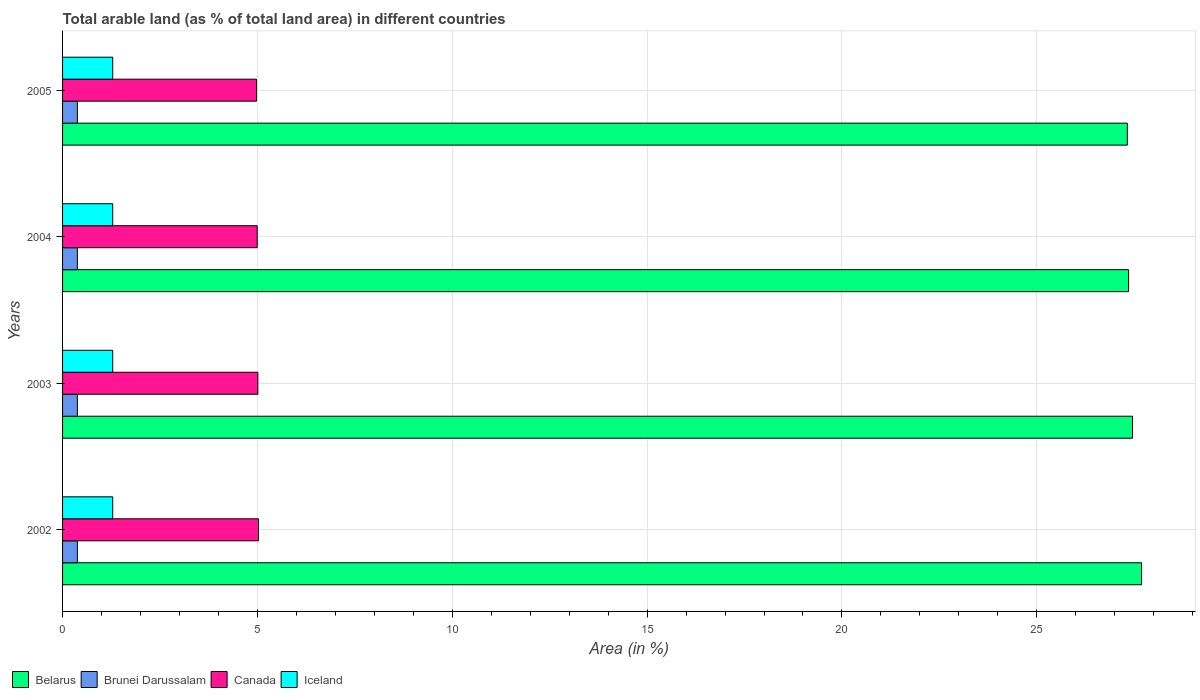Are the number of bars per tick equal to the number of legend labels?
Your answer should be compact. Yes. What is the percentage of arable land in Belarus in 2003?
Provide a short and direct response. 27.46. Across all years, what is the maximum percentage of arable land in Iceland?
Give a very brief answer. 1.29. Across all years, what is the minimum percentage of arable land in Belarus?
Give a very brief answer. 27.32. In which year was the percentage of arable land in Belarus minimum?
Keep it short and to the point. 2005. What is the total percentage of arable land in Brunei Darussalam in the graph?
Keep it short and to the point. 1.52. What is the difference between the percentage of arable land in Iceland in 2004 and the percentage of arable land in Brunei Darussalam in 2002?
Give a very brief answer. 0.91. What is the average percentage of arable land in Belarus per year?
Your response must be concise. 27.46. In the year 2005, what is the difference between the percentage of arable land in Brunei Darussalam and percentage of arable land in Canada?
Provide a succinct answer. -4.6. What is the ratio of the percentage of arable land in Canada in 2002 to that in 2003?
Keep it short and to the point. 1. What is the difference between the highest and the second highest percentage of arable land in Canada?
Your answer should be compact. 0.02. What is the difference between the highest and the lowest percentage of arable land in Belarus?
Make the answer very short. 0.36. In how many years, is the percentage of arable land in Canada greater than the average percentage of arable land in Canada taken over all years?
Provide a short and direct response. 2. Is the sum of the percentage of arable land in Belarus in 2003 and 2005 greater than the maximum percentage of arable land in Brunei Darussalam across all years?
Provide a succinct answer. Yes. Is it the case that in every year, the sum of the percentage of arable land in Iceland and percentage of arable land in Belarus is greater than the sum of percentage of arable land in Canada and percentage of arable land in Brunei Darussalam?
Offer a terse response. Yes. What does the 3rd bar from the top in 2005 represents?
Give a very brief answer. Brunei Darussalam. What does the 2nd bar from the bottom in 2005 represents?
Offer a very short reply. Brunei Darussalam. How many bars are there?
Offer a terse response. 16. Are all the bars in the graph horizontal?
Your answer should be compact. Yes. What is the difference between two consecutive major ticks on the X-axis?
Offer a terse response. 5. Where does the legend appear in the graph?
Your response must be concise. Bottom left. How many legend labels are there?
Make the answer very short. 4. How are the legend labels stacked?
Offer a very short reply. Horizontal. What is the title of the graph?
Provide a succinct answer. Total arable land (as % of total land area) in different countries. Does "Botswana" appear as one of the legend labels in the graph?
Ensure brevity in your answer.  No. What is the label or title of the X-axis?
Provide a short and direct response. Area (in %). What is the label or title of the Y-axis?
Give a very brief answer. Years. What is the Area (in %) of Belarus in 2002?
Provide a succinct answer. 27.69. What is the Area (in %) of Brunei Darussalam in 2002?
Provide a succinct answer. 0.38. What is the Area (in %) of Canada in 2002?
Offer a very short reply. 5.03. What is the Area (in %) of Iceland in 2002?
Give a very brief answer. 1.29. What is the Area (in %) in Belarus in 2003?
Provide a short and direct response. 27.46. What is the Area (in %) in Brunei Darussalam in 2003?
Provide a short and direct response. 0.38. What is the Area (in %) of Canada in 2003?
Keep it short and to the point. 5.01. What is the Area (in %) in Iceland in 2003?
Provide a short and direct response. 1.29. What is the Area (in %) of Belarus in 2004?
Ensure brevity in your answer.  27.36. What is the Area (in %) in Brunei Darussalam in 2004?
Offer a terse response. 0.38. What is the Area (in %) in Canada in 2004?
Give a very brief answer. 4.99. What is the Area (in %) of Iceland in 2004?
Give a very brief answer. 1.29. What is the Area (in %) of Belarus in 2005?
Provide a short and direct response. 27.32. What is the Area (in %) in Brunei Darussalam in 2005?
Provide a short and direct response. 0.38. What is the Area (in %) of Canada in 2005?
Your answer should be very brief. 4.98. What is the Area (in %) of Iceland in 2005?
Your answer should be compact. 1.29. Across all years, what is the maximum Area (in %) of Belarus?
Your response must be concise. 27.69. Across all years, what is the maximum Area (in %) of Brunei Darussalam?
Give a very brief answer. 0.38. Across all years, what is the maximum Area (in %) in Canada?
Ensure brevity in your answer.  5.03. Across all years, what is the maximum Area (in %) in Iceland?
Offer a terse response. 1.29. Across all years, what is the minimum Area (in %) of Belarus?
Your answer should be very brief. 27.32. Across all years, what is the minimum Area (in %) of Brunei Darussalam?
Give a very brief answer. 0.38. Across all years, what is the minimum Area (in %) of Canada?
Make the answer very short. 4.98. Across all years, what is the minimum Area (in %) of Iceland?
Your answer should be very brief. 1.29. What is the total Area (in %) in Belarus in the graph?
Offer a terse response. 109.82. What is the total Area (in %) of Brunei Darussalam in the graph?
Keep it short and to the point. 1.52. What is the total Area (in %) in Canada in the graph?
Give a very brief answer. 20.01. What is the total Area (in %) in Iceland in the graph?
Offer a very short reply. 5.15. What is the difference between the Area (in %) of Belarus in 2002 and that in 2003?
Ensure brevity in your answer.  0.23. What is the difference between the Area (in %) in Brunei Darussalam in 2002 and that in 2003?
Your answer should be compact. 0. What is the difference between the Area (in %) of Canada in 2002 and that in 2003?
Make the answer very short. 0.02. What is the difference between the Area (in %) of Belarus in 2002 and that in 2004?
Keep it short and to the point. 0.33. What is the difference between the Area (in %) of Brunei Darussalam in 2002 and that in 2004?
Provide a succinct answer. 0. What is the difference between the Area (in %) of Canada in 2002 and that in 2004?
Offer a very short reply. 0.03. What is the difference between the Area (in %) in Iceland in 2002 and that in 2004?
Offer a very short reply. 0. What is the difference between the Area (in %) of Belarus in 2002 and that in 2005?
Your response must be concise. 0.36. What is the difference between the Area (in %) of Canada in 2002 and that in 2005?
Your response must be concise. 0.05. What is the difference between the Area (in %) of Iceland in 2002 and that in 2005?
Provide a short and direct response. 0. What is the difference between the Area (in %) of Belarus in 2003 and that in 2004?
Your response must be concise. 0.1. What is the difference between the Area (in %) of Canada in 2003 and that in 2004?
Offer a very short reply. 0.02. What is the difference between the Area (in %) in Belarus in 2003 and that in 2005?
Make the answer very short. 0.13. What is the difference between the Area (in %) in Brunei Darussalam in 2003 and that in 2005?
Ensure brevity in your answer.  0. What is the difference between the Area (in %) in Canada in 2003 and that in 2005?
Offer a terse response. 0.03. What is the difference between the Area (in %) in Iceland in 2003 and that in 2005?
Give a very brief answer. 0. What is the difference between the Area (in %) in Belarus in 2004 and that in 2005?
Keep it short and to the point. 0.03. What is the difference between the Area (in %) in Brunei Darussalam in 2004 and that in 2005?
Keep it short and to the point. 0. What is the difference between the Area (in %) in Canada in 2004 and that in 2005?
Provide a succinct answer. 0.02. What is the difference between the Area (in %) in Belarus in 2002 and the Area (in %) in Brunei Darussalam in 2003?
Give a very brief answer. 27.31. What is the difference between the Area (in %) of Belarus in 2002 and the Area (in %) of Canada in 2003?
Your answer should be very brief. 22.68. What is the difference between the Area (in %) of Belarus in 2002 and the Area (in %) of Iceland in 2003?
Offer a terse response. 26.4. What is the difference between the Area (in %) in Brunei Darussalam in 2002 and the Area (in %) in Canada in 2003?
Offer a very short reply. -4.63. What is the difference between the Area (in %) in Brunei Darussalam in 2002 and the Area (in %) in Iceland in 2003?
Offer a terse response. -0.91. What is the difference between the Area (in %) of Canada in 2002 and the Area (in %) of Iceland in 2003?
Make the answer very short. 3.74. What is the difference between the Area (in %) of Belarus in 2002 and the Area (in %) of Brunei Darussalam in 2004?
Offer a terse response. 27.31. What is the difference between the Area (in %) in Belarus in 2002 and the Area (in %) in Canada in 2004?
Offer a terse response. 22.69. What is the difference between the Area (in %) of Belarus in 2002 and the Area (in %) of Iceland in 2004?
Your response must be concise. 26.4. What is the difference between the Area (in %) in Brunei Darussalam in 2002 and the Area (in %) in Canada in 2004?
Make the answer very short. -4.62. What is the difference between the Area (in %) in Brunei Darussalam in 2002 and the Area (in %) in Iceland in 2004?
Make the answer very short. -0.91. What is the difference between the Area (in %) of Canada in 2002 and the Area (in %) of Iceland in 2004?
Offer a very short reply. 3.74. What is the difference between the Area (in %) in Belarus in 2002 and the Area (in %) in Brunei Darussalam in 2005?
Your answer should be very brief. 27.31. What is the difference between the Area (in %) of Belarus in 2002 and the Area (in %) of Canada in 2005?
Provide a short and direct response. 22.71. What is the difference between the Area (in %) in Belarus in 2002 and the Area (in %) in Iceland in 2005?
Make the answer very short. 26.4. What is the difference between the Area (in %) in Brunei Darussalam in 2002 and the Area (in %) in Canada in 2005?
Give a very brief answer. -4.6. What is the difference between the Area (in %) in Brunei Darussalam in 2002 and the Area (in %) in Iceland in 2005?
Give a very brief answer. -0.91. What is the difference between the Area (in %) of Canada in 2002 and the Area (in %) of Iceland in 2005?
Your response must be concise. 3.74. What is the difference between the Area (in %) in Belarus in 2003 and the Area (in %) in Brunei Darussalam in 2004?
Your answer should be very brief. 27.08. What is the difference between the Area (in %) in Belarus in 2003 and the Area (in %) in Canada in 2004?
Your answer should be very brief. 22.46. What is the difference between the Area (in %) of Belarus in 2003 and the Area (in %) of Iceland in 2004?
Make the answer very short. 26.17. What is the difference between the Area (in %) in Brunei Darussalam in 2003 and the Area (in %) in Canada in 2004?
Your answer should be very brief. -4.62. What is the difference between the Area (in %) of Brunei Darussalam in 2003 and the Area (in %) of Iceland in 2004?
Offer a terse response. -0.91. What is the difference between the Area (in %) in Canada in 2003 and the Area (in %) in Iceland in 2004?
Provide a short and direct response. 3.72. What is the difference between the Area (in %) of Belarus in 2003 and the Area (in %) of Brunei Darussalam in 2005?
Provide a short and direct response. 27.08. What is the difference between the Area (in %) in Belarus in 2003 and the Area (in %) in Canada in 2005?
Your answer should be very brief. 22.48. What is the difference between the Area (in %) in Belarus in 2003 and the Area (in %) in Iceland in 2005?
Make the answer very short. 26.17. What is the difference between the Area (in %) of Brunei Darussalam in 2003 and the Area (in %) of Canada in 2005?
Keep it short and to the point. -4.6. What is the difference between the Area (in %) in Brunei Darussalam in 2003 and the Area (in %) in Iceland in 2005?
Keep it short and to the point. -0.91. What is the difference between the Area (in %) of Canada in 2003 and the Area (in %) of Iceland in 2005?
Offer a very short reply. 3.72. What is the difference between the Area (in %) in Belarus in 2004 and the Area (in %) in Brunei Darussalam in 2005?
Your answer should be compact. 26.98. What is the difference between the Area (in %) in Belarus in 2004 and the Area (in %) in Canada in 2005?
Your answer should be compact. 22.38. What is the difference between the Area (in %) in Belarus in 2004 and the Area (in %) in Iceland in 2005?
Ensure brevity in your answer.  26.07. What is the difference between the Area (in %) in Brunei Darussalam in 2004 and the Area (in %) in Canada in 2005?
Your response must be concise. -4.6. What is the difference between the Area (in %) of Brunei Darussalam in 2004 and the Area (in %) of Iceland in 2005?
Make the answer very short. -0.91. What is the difference between the Area (in %) in Canada in 2004 and the Area (in %) in Iceland in 2005?
Give a very brief answer. 3.71. What is the average Area (in %) in Belarus per year?
Ensure brevity in your answer.  27.46. What is the average Area (in %) of Brunei Darussalam per year?
Offer a terse response. 0.38. What is the average Area (in %) in Canada per year?
Your response must be concise. 5. What is the average Area (in %) in Iceland per year?
Keep it short and to the point. 1.29. In the year 2002, what is the difference between the Area (in %) of Belarus and Area (in %) of Brunei Darussalam?
Make the answer very short. 27.31. In the year 2002, what is the difference between the Area (in %) of Belarus and Area (in %) of Canada?
Offer a very short reply. 22.66. In the year 2002, what is the difference between the Area (in %) in Belarus and Area (in %) in Iceland?
Your answer should be very brief. 26.4. In the year 2002, what is the difference between the Area (in %) of Brunei Darussalam and Area (in %) of Canada?
Offer a very short reply. -4.65. In the year 2002, what is the difference between the Area (in %) in Brunei Darussalam and Area (in %) in Iceland?
Give a very brief answer. -0.91. In the year 2002, what is the difference between the Area (in %) of Canada and Area (in %) of Iceland?
Offer a terse response. 3.74. In the year 2003, what is the difference between the Area (in %) in Belarus and Area (in %) in Brunei Darussalam?
Give a very brief answer. 27.08. In the year 2003, what is the difference between the Area (in %) in Belarus and Area (in %) in Canada?
Provide a succinct answer. 22.44. In the year 2003, what is the difference between the Area (in %) in Belarus and Area (in %) in Iceland?
Ensure brevity in your answer.  26.17. In the year 2003, what is the difference between the Area (in %) in Brunei Darussalam and Area (in %) in Canada?
Make the answer very short. -4.63. In the year 2003, what is the difference between the Area (in %) in Brunei Darussalam and Area (in %) in Iceland?
Make the answer very short. -0.91. In the year 2003, what is the difference between the Area (in %) of Canada and Area (in %) of Iceland?
Offer a terse response. 3.72. In the year 2004, what is the difference between the Area (in %) in Belarus and Area (in %) in Brunei Darussalam?
Your response must be concise. 26.98. In the year 2004, what is the difference between the Area (in %) in Belarus and Area (in %) in Canada?
Your answer should be very brief. 22.36. In the year 2004, what is the difference between the Area (in %) of Belarus and Area (in %) of Iceland?
Your answer should be compact. 26.07. In the year 2004, what is the difference between the Area (in %) of Brunei Darussalam and Area (in %) of Canada?
Offer a terse response. -4.62. In the year 2004, what is the difference between the Area (in %) in Brunei Darussalam and Area (in %) in Iceland?
Keep it short and to the point. -0.91. In the year 2004, what is the difference between the Area (in %) in Canada and Area (in %) in Iceland?
Provide a short and direct response. 3.71. In the year 2005, what is the difference between the Area (in %) of Belarus and Area (in %) of Brunei Darussalam?
Give a very brief answer. 26.94. In the year 2005, what is the difference between the Area (in %) in Belarus and Area (in %) in Canada?
Your answer should be very brief. 22.35. In the year 2005, what is the difference between the Area (in %) in Belarus and Area (in %) in Iceland?
Ensure brevity in your answer.  26.04. In the year 2005, what is the difference between the Area (in %) in Brunei Darussalam and Area (in %) in Canada?
Your response must be concise. -4.6. In the year 2005, what is the difference between the Area (in %) in Brunei Darussalam and Area (in %) in Iceland?
Provide a short and direct response. -0.91. In the year 2005, what is the difference between the Area (in %) of Canada and Area (in %) of Iceland?
Provide a succinct answer. 3.69. What is the ratio of the Area (in %) of Belarus in 2002 to that in 2003?
Provide a succinct answer. 1.01. What is the ratio of the Area (in %) of Brunei Darussalam in 2002 to that in 2003?
Offer a very short reply. 1. What is the ratio of the Area (in %) in Belarus in 2002 to that in 2004?
Make the answer very short. 1.01. What is the ratio of the Area (in %) in Brunei Darussalam in 2002 to that in 2004?
Provide a succinct answer. 1. What is the ratio of the Area (in %) in Canada in 2002 to that in 2004?
Make the answer very short. 1.01. What is the ratio of the Area (in %) in Iceland in 2002 to that in 2004?
Your answer should be compact. 1. What is the ratio of the Area (in %) of Belarus in 2002 to that in 2005?
Ensure brevity in your answer.  1.01. What is the ratio of the Area (in %) of Canada in 2002 to that in 2005?
Ensure brevity in your answer.  1.01. What is the ratio of the Area (in %) in Iceland in 2002 to that in 2005?
Give a very brief answer. 1. What is the ratio of the Area (in %) of Canada in 2003 to that in 2005?
Your answer should be compact. 1.01. What is the ratio of the Area (in %) in Belarus in 2004 to that in 2005?
Offer a very short reply. 1. What is the ratio of the Area (in %) of Brunei Darussalam in 2004 to that in 2005?
Your answer should be compact. 1. What is the difference between the highest and the second highest Area (in %) of Belarus?
Give a very brief answer. 0.23. What is the difference between the highest and the second highest Area (in %) of Canada?
Provide a short and direct response. 0.02. What is the difference between the highest and the second highest Area (in %) in Iceland?
Your answer should be compact. 0. What is the difference between the highest and the lowest Area (in %) of Belarus?
Provide a short and direct response. 0.36. What is the difference between the highest and the lowest Area (in %) in Brunei Darussalam?
Your answer should be compact. 0. What is the difference between the highest and the lowest Area (in %) in Canada?
Keep it short and to the point. 0.05. What is the difference between the highest and the lowest Area (in %) of Iceland?
Offer a very short reply. 0. 